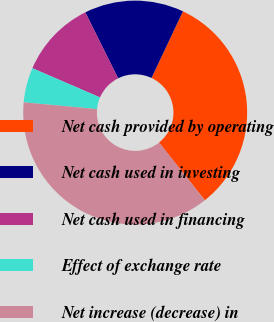Convert chart. <chart><loc_0><loc_0><loc_500><loc_500><pie_chart><fcel>Net cash provided by operating<fcel>Net cash used in investing<fcel>Net cash used in financing<fcel>Effect of exchange rate<fcel>Net increase (decrease) in<nl><fcel>32.3%<fcel>14.37%<fcel>11.16%<fcel>5.03%<fcel>37.15%<nl></chart> 